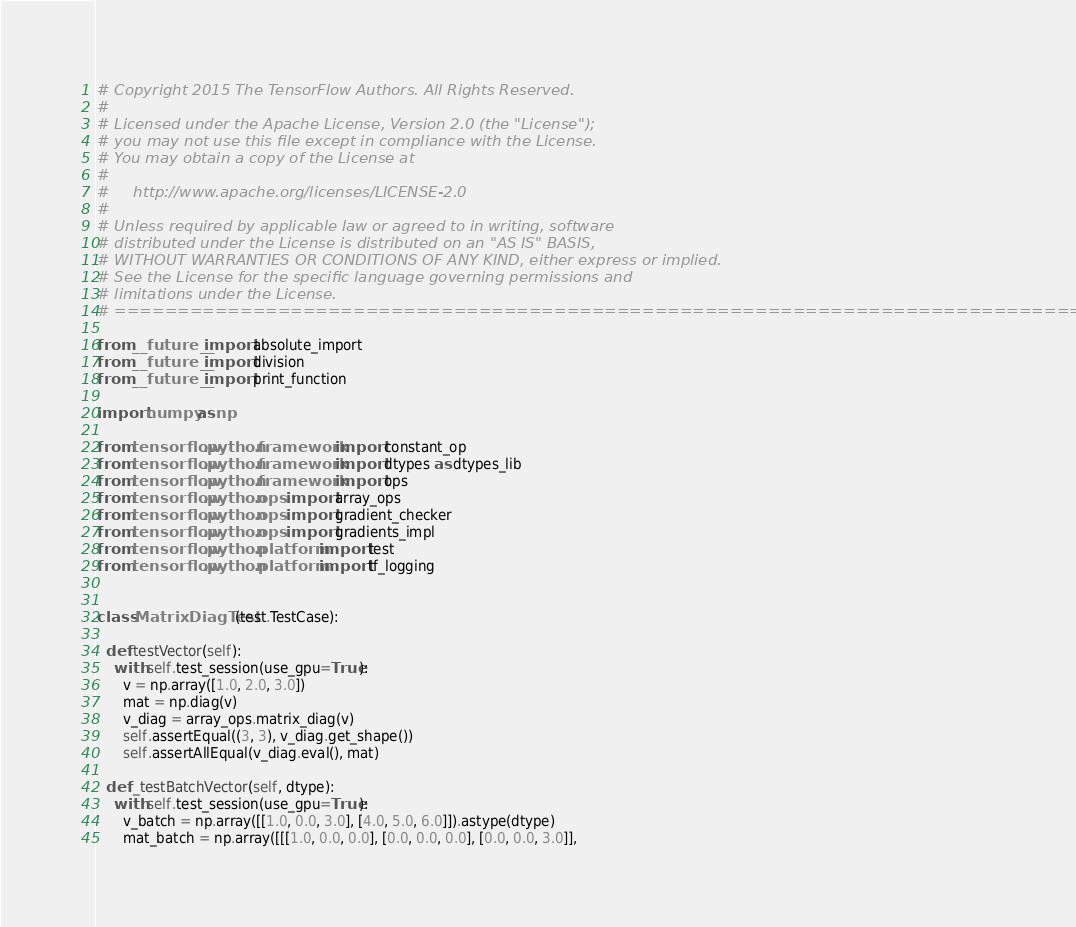Convert code to text. <code><loc_0><loc_0><loc_500><loc_500><_Python_># Copyright 2015 The TensorFlow Authors. All Rights Reserved.
#
# Licensed under the Apache License, Version 2.0 (the "License");
# you may not use this file except in compliance with the License.
# You may obtain a copy of the License at
#
#     http://www.apache.org/licenses/LICENSE-2.0
#
# Unless required by applicable law or agreed to in writing, software
# distributed under the License is distributed on an "AS IS" BASIS,
# WITHOUT WARRANTIES OR CONDITIONS OF ANY KIND, either express or implied.
# See the License for the specific language governing permissions and
# limitations under the License.
# ==============================================================================

from __future__ import absolute_import
from __future__ import division
from __future__ import print_function

import numpy as np

from tensorflow.python.framework import constant_op
from tensorflow.python.framework import dtypes as dtypes_lib
from tensorflow.python.framework import ops
from tensorflow.python.ops import array_ops
from tensorflow.python.ops import gradient_checker
from tensorflow.python.ops import gradients_impl
from tensorflow.python.platform import test
from tensorflow.python.platform import tf_logging


class MatrixDiagTest(test.TestCase):

  def testVector(self):
    with self.test_session(use_gpu=True):
      v = np.array([1.0, 2.0, 3.0])
      mat = np.diag(v)
      v_diag = array_ops.matrix_diag(v)
      self.assertEqual((3, 3), v_diag.get_shape())
      self.assertAllEqual(v_diag.eval(), mat)

  def _testBatchVector(self, dtype):
    with self.test_session(use_gpu=True):
      v_batch = np.array([[1.0, 0.0, 3.0], [4.0, 5.0, 6.0]]).astype(dtype)
      mat_batch = np.array([[[1.0, 0.0, 0.0], [0.0, 0.0, 0.0], [0.0, 0.0, 3.0]],</code> 